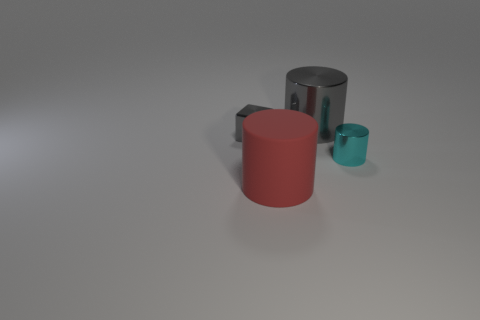What materials do these objects seem to be made of, and how does that affect their appearance? The red object appears to be made of rubber, which gives it a matte and slightly textured appearance. The gray cylinder seems to be metallic, likely steel or aluminum, which is why it has a reflective and smoother surface. These materials influence the objects' textures, light reflection properties, and overall visual impressions. 